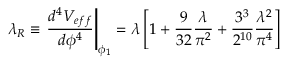Convert formula to latex. <formula><loc_0><loc_0><loc_500><loc_500>\lambda _ { R } \equiv \frac { d ^ { 4 } V _ { e f f } } { d \phi ^ { 4 } } \right | _ { \phi _ { 1 } } = \lambda \left [ 1 + \frac { 9 } { 3 2 } \frac { \lambda } { \pi ^ { 2 } } + \frac { 3 ^ { 3 } } { 2 ^ { 1 0 } } \frac { \lambda ^ { 2 } } { \pi ^ { 4 } } \right ]</formula> 